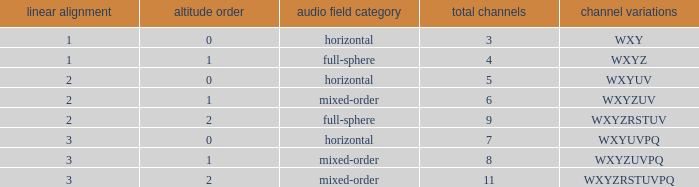If the channels is wxyzrstuvpq, what is the horizontal order? 3.0. 